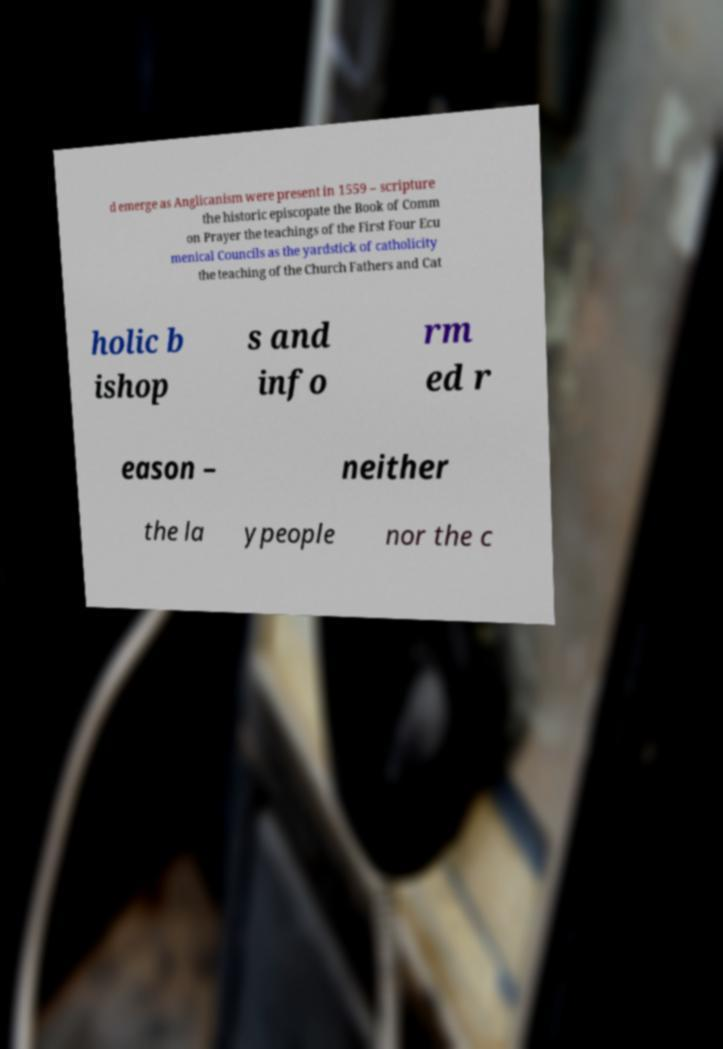Please identify and transcribe the text found in this image. d emerge as Anglicanism were present in 1559 – scripture the historic episcopate the Book of Comm on Prayer the teachings of the First Four Ecu menical Councils as the yardstick of catholicity the teaching of the Church Fathers and Cat holic b ishop s and info rm ed r eason – neither the la ypeople nor the c 